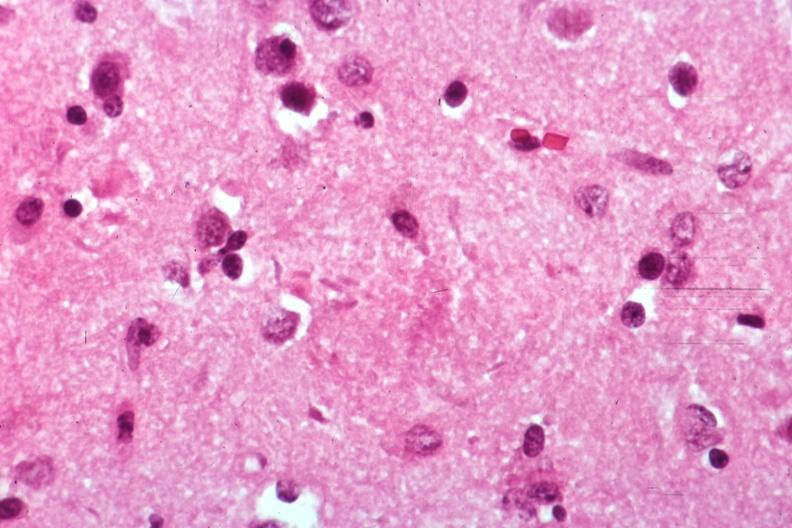does astrocytoma show neural tangle?
Answer the question using a single word or phrase. No 